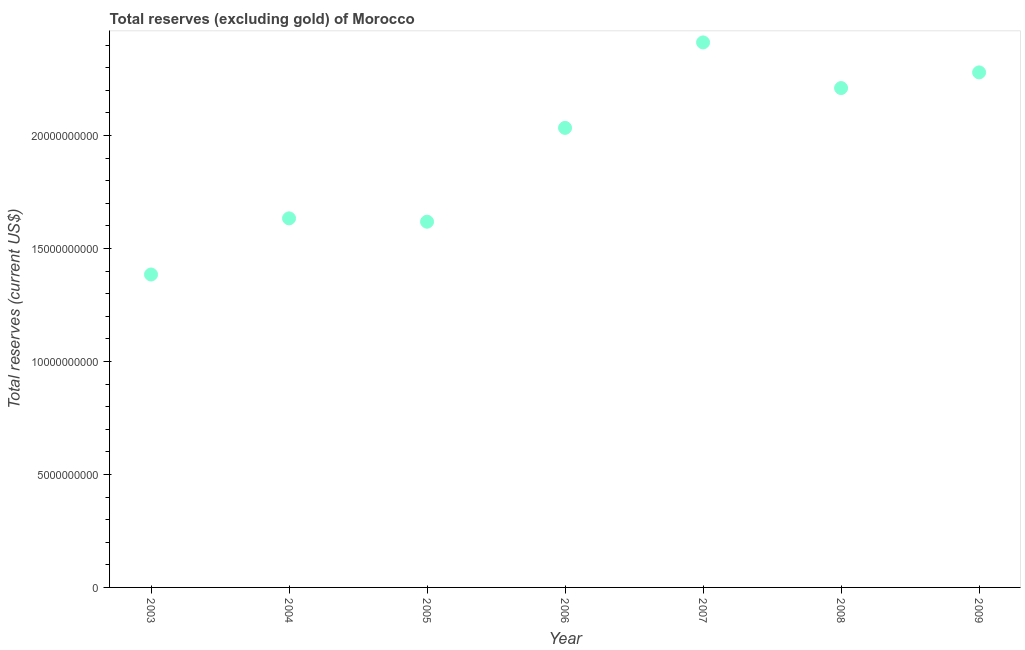What is the total reserves (excluding gold) in 2006?
Give a very brief answer. 2.03e+1. Across all years, what is the maximum total reserves (excluding gold)?
Your answer should be very brief. 2.41e+1. Across all years, what is the minimum total reserves (excluding gold)?
Give a very brief answer. 1.39e+1. In which year was the total reserves (excluding gold) maximum?
Offer a very short reply. 2007. In which year was the total reserves (excluding gold) minimum?
Provide a short and direct response. 2003. What is the sum of the total reserves (excluding gold)?
Make the answer very short. 1.36e+11. What is the difference between the total reserves (excluding gold) in 2004 and 2007?
Offer a very short reply. -7.79e+09. What is the average total reserves (excluding gold) per year?
Offer a terse response. 1.94e+1. What is the median total reserves (excluding gold)?
Your answer should be compact. 2.03e+1. What is the ratio of the total reserves (excluding gold) in 2008 to that in 2009?
Keep it short and to the point. 0.97. Is the total reserves (excluding gold) in 2003 less than that in 2007?
Ensure brevity in your answer.  Yes. What is the difference between the highest and the second highest total reserves (excluding gold)?
Keep it short and to the point. 1.33e+09. Is the sum of the total reserves (excluding gold) in 2003 and 2006 greater than the maximum total reserves (excluding gold) across all years?
Your response must be concise. Yes. What is the difference between the highest and the lowest total reserves (excluding gold)?
Your response must be concise. 1.03e+1. In how many years, is the total reserves (excluding gold) greater than the average total reserves (excluding gold) taken over all years?
Your answer should be very brief. 4. Does the total reserves (excluding gold) monotonically increase over the years?
Offer a terse response. No. How many years are there in the graph?
Offer a very short reply. 7. Does the graph contain grids?
Provide a short and direct response. No. What is the title of the graph?
Give a very brief answer. Total reserves (excluding gold) of Morocco. What is the label or title of the X-axis?
Your answer should be compact. Year. What is the label or title of the Y-axis?
Make the answer very short. Total reserves (current US$). What is the Total reserves (current US$) in 2003?
Your response must be concise. 1.39e+1. What is the Total reserves (current US$) in 2004?
Provide a short and direct response. 1.63e+1. What is the Total reserves (current US$) in 2005?
Offer a terse response. 1.62e+1. What is the Total reserves (current US$) in 2006?
Offer a very short reply. 2.03e+1. What is the Total reserves (current US$) in 2007?
Provide a short and direct response. 2.41e+1. What is the Total reserves (current US$) in 2008?
Provide a short and direct response. 2.21e+1. What is the Total reserves (current US$) in 2009?
Give a very brief answer. 2.28e+1. What is the difference between the Total reserves (current US$) in 2003 and 2004?
Your answer should be compact. -2.49e+09. What is the difference between the Total reserves (current US$) in 2003 and 2005?
Keep it short and to the point. -2.34e+09. What is the difference between the Total reserves (current US$) in 2003 and 2006?
Your response must be concise. -6.49e+09. What is the difference between the Total reserves (current US$) in 2003 and 2007?
Your answer should be compact. -1.03e+1. What is the difference between the Total reserves (current US$) in 2003 and 2008?
Offer a terse response. -8.25e+09. What is the difference between the Total reserves (current US$) in 2003 and 2009?
Your answer should be very brief. -8.95e+09. What is the difference between the Total reserves (current US$) in 2004 and 2005?
Your answer should be compact. 1.49e+08. What is the difference between the Total reserves (current US$) in 2004 and 2006?
Make the answer very short. -4.00e+09. What is the difference between the Total reserves (current US$) in 2004 and 2007?
Offer a very short reply. -7.79e+09. What is the difference between the Total reserves (current US$) in 2004 and 2008?
Offer a terse response. -5.77e+09. What is the difference between the Total reserves (current US$) in 2004 and 2009?
Provide a succinct answer. -6.46e+09. What is the difference between the Total reserves (current US$) in 2005 and 2006?
Give a very brief answer. -4.15e+09. What is the difference between the Total reserves (current US$) in 2005 and 2007?
Keep it short and to the point. -7.94e+09. What is the difference between the Total reserves (current US$) in 2005 and 2008?
Your response must be concise. -5.92e+09. What is the difference between the Total reserves (current US$) in 2005 and 2009?
Provide a short and direct response. -6.61e+09. What is the difference between the Total reserves (current US$) in 2006 and 2007?
Your response must be concise. -3.78e+09. What is the difference between the Total reserves (current US$) in 2006 and 2008?
Offer a terse response. -1.76e+09. What is the difference between the Total reserves (current US$) in 2006 and 2009?
Make the answer very short. -2.46e+09. What is the difference between the Total reserves (current US$) in 2007 and 2008?
Your answer should be compact. 2.02e+09. What is the difference between the Total reserves (current US$) in 2007 and 2009?
Make the answer very short. 1.33e+09. What is the difference between the Total reserves (current US$) in 2008 and 2009?
Your response must be concise. -6.94e+08. What is the ratio of the Total reserves (current US$) in 2003 to that in 2004?
Make the answer very short. 0.85. What is the ratio of the Total reserves (current US$) in 2003 to that in 2005?
Your response must be concise. 0.86. What is the ratio of the Total reserves (current US$) in 2003 to that in 2006?
Ensure brevity in your answer.  0.68. What is the ratio of the Total reserves (current US$) in 2003 to that in 2007?
Make the answer very short. 0.57. What is the ratio of the Total reserves (current US$) in 2003 to that in 2008?
Provide a succinct answer. 0.63. What is the ratio of the Total reserves (current US$) in 2003 to that in 2009?
Provide a succinct answer. 0.61. What is the ratio of the Total reserves (current US$) in 2004 to that in 2006?
Provide a succinct answer. 0.8. What is the ratio of the Total reserves (current US$) in 2004 to that in 2007?
Your response must be concise. 0.68. What is the ratio of the Total reserves (current US$) in 2004 to that in 2008?
Offer a terse response. 0.74. What is the ratio of the Total reserves (current US$) in 2004 to that in 2009?
Give a very brief answer. 0.72. What is the ratio of the Total reserves (current US$) in 2005 to that in 2006?
Provide a short and direct response. 0.8. What is the ratio of the Total reserves (current US$) in 2005 to that in 2007?
Your response must be concise. 0.67. What is the ratio of the Total reserves (current US$) in 2005 to that in 2008?
Your response must be concise. 0.73. What is the ratio of the Total reserves (current US$) in 2005 to that in 2009?
Your answer should be very brief. 0.71. What is the ratio of the Total reserves (current US$) in 2006 to that in 2007?
Offer a very short reply. 0.84. What is the ratio of the Total reserves (current US$) in 2006 to that in 2009?
Give a very brief answer. 0.89. What is the ratio of the Total reserves (current US$) in 2007 to that in 2008?
Make the answer very short. 1.09. What is the ratio of the Total reserves (current US$) in 2007 to that in 2009?
Provide a short and direct response. 1.06. What is the ratio of the Total reserves (current US$) in 2008 to that in 2009?
Give a very brief answer. 0.97. 